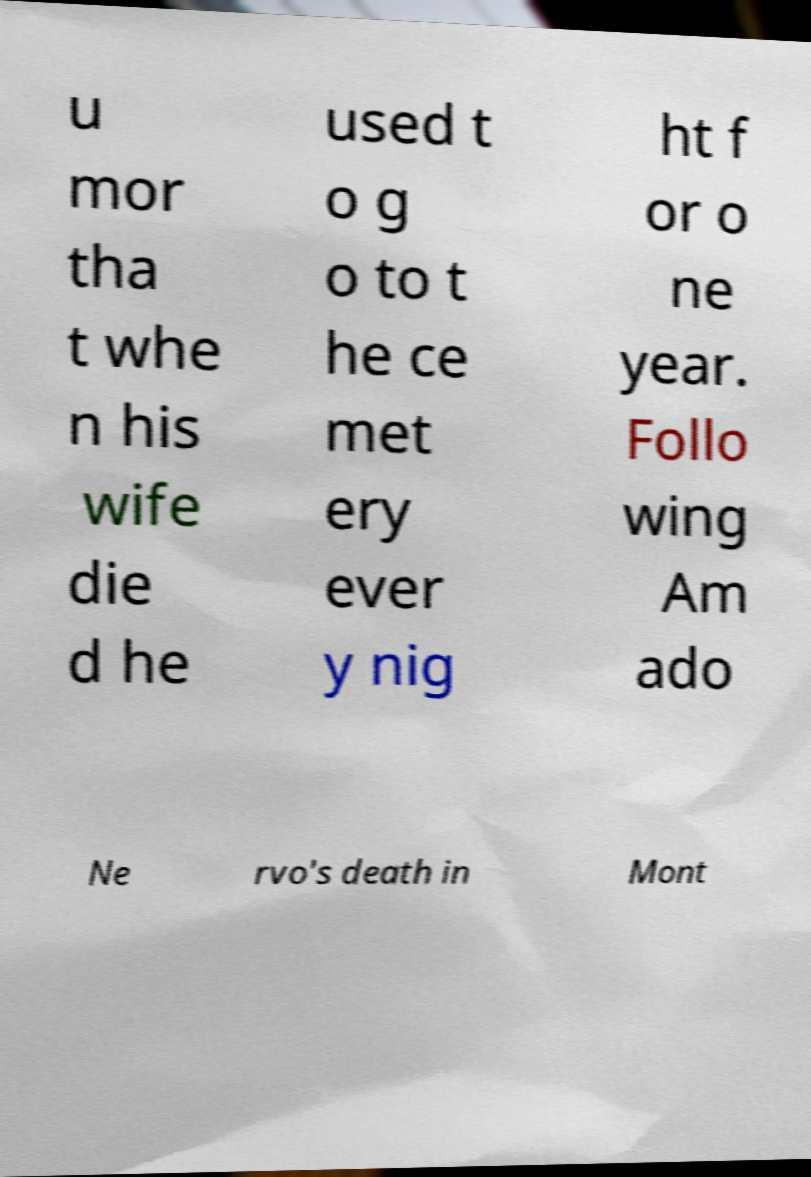Could you extract and type out the text from this image? u mor tha t whe n his wife die d he used t o g o to t he ce met ery ever y nig ht f or o ne year. Follo wing Am ado Ne rvo's death in Mont 